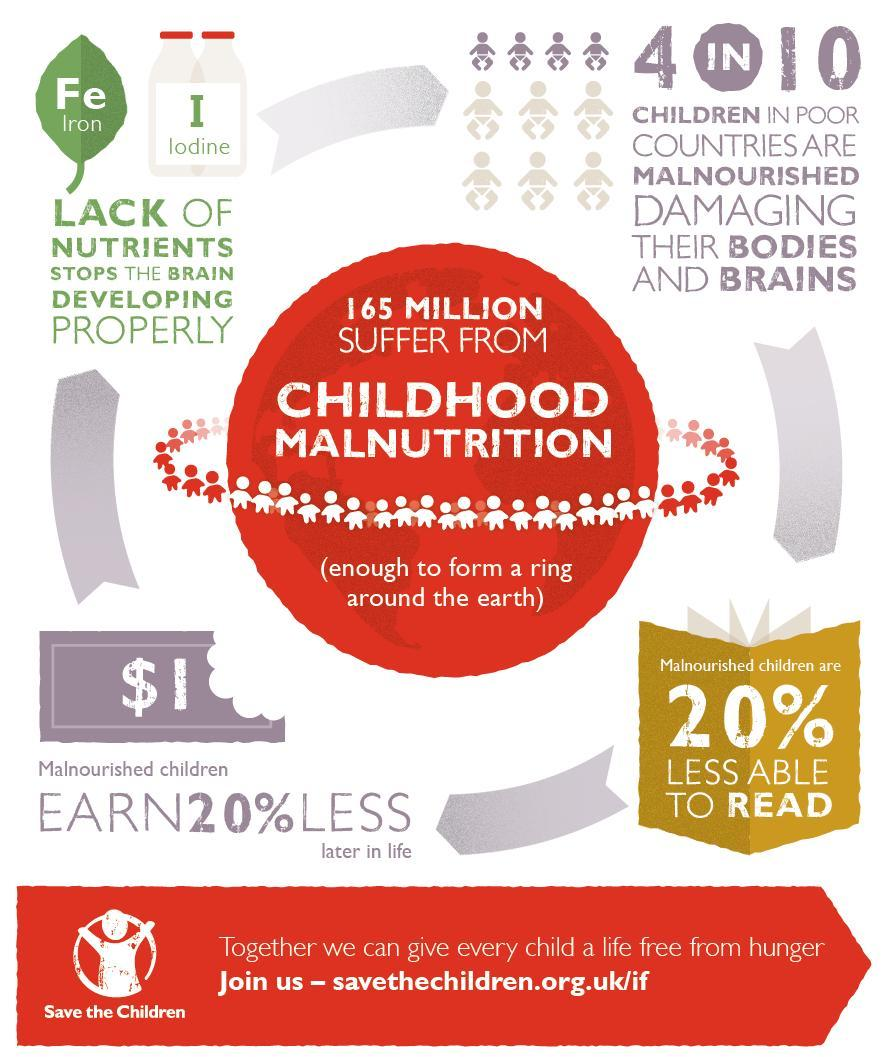What stops proper brain development?
Answer the question with a short phrase. Lack of nutrients What is the total number children suffering from malnutrition? 165 million What condition caused damage to bodies and brains in children? malnourished The names of which two nutrients are given in this image? Iron, Iodine 